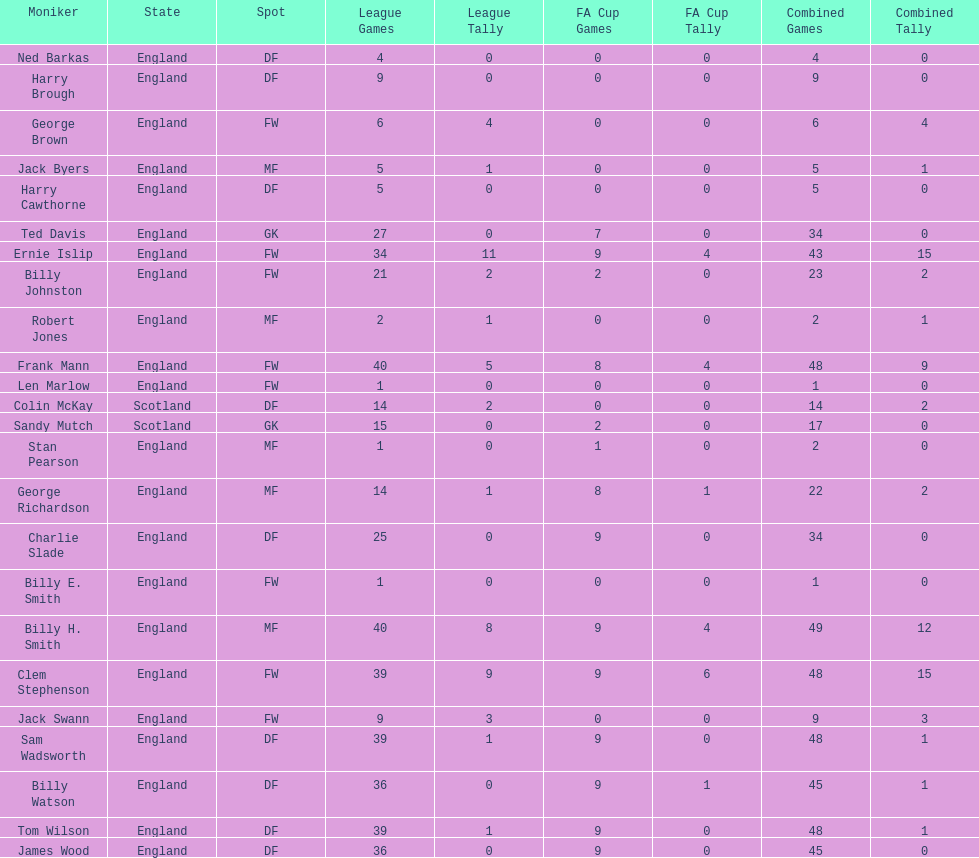What are the number of league apps ted davis has? 27. 